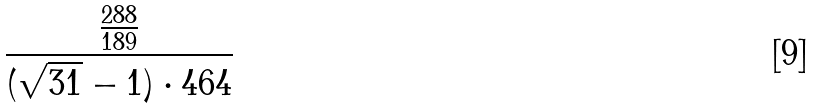Convert formula to latex. <formula><loc_0><loc_0><loc_500><loc_500>\frac { \frac { 2 8 8 } { 1 8 9 } } { ( \sqrt { 3 1 } - 1 ) \cdot 4 6 4 }</formula> 